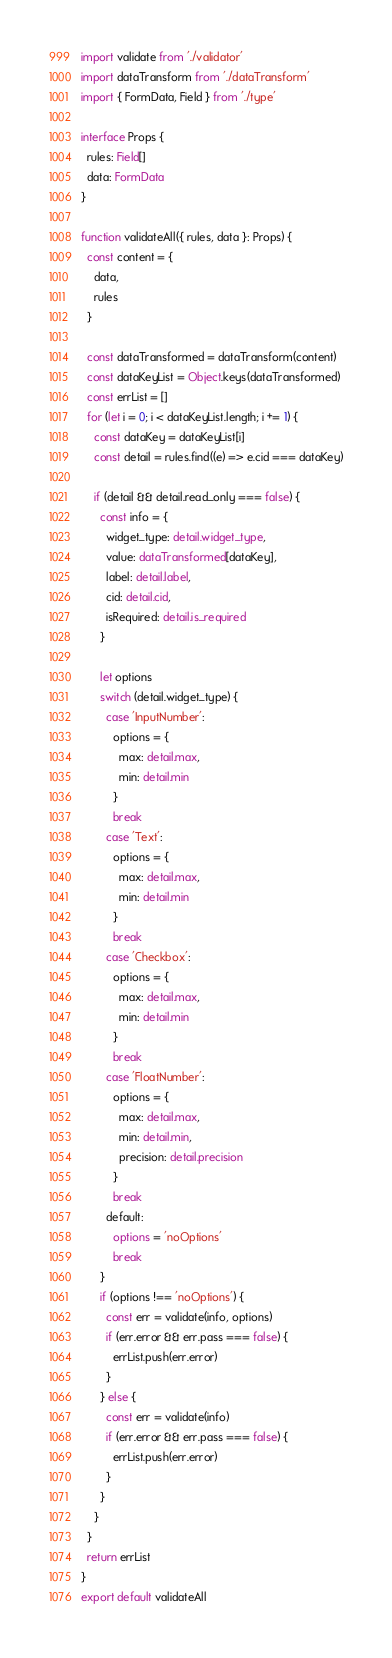Convert code to text. <code><loc_0><loc_0><loc_500><loc_500><_TypeScript_>import validate from './validator'
import dataTransform from './dataTransform'
import { FormData, Field } from './type'

interface Props {
  rules: Field[]
  data: FormData
}

function validateAll({ rules, data }: Props) {
  const content = {
    data,
    rules
  }

  const dataTransformed = dataTransform(content)
  const dataKeyList = Object.keys(dataTransformed)
  const errList = []
  for (let i = 0; i < dataKeyList.length; i += 1) {
    const dataKey = dataKeyList[i]
    const detail = rules.find((e) => e.cid === dataKey)

    if (detail && detail.read_only === false) {
      const info = {
        widget_type: detail.widget_type,
        value: dataTransformed[dataKey],
        label: detail.label,
        cid: detail.cid,
        isRequired: detail.is_required
      }

      let options
      switch (detail.widget_type) {
        case 'InputNumber':
          options = {
            max: detail.max,
            min: detail.min
          }
          break
        case 'Text':
          options = {
            max: detail.max,
            min: detail.min
          }
          break
        case 'Checkbox':
          options = {
            max: detail.max,
            min: detail.min
          }
          break
        case 'FloatNumber':
          options = {
            max: detail.max,
            min: detail.min,
            precision: detail.precision
          }
          break
        default:
          options = 'noOptions'
          break
      }
      if (options !== 'noOptions') {
        const err = validate(info, options)
        if (err.error && err.pass === false) {
          errList.push(err.error)
        }
      } else {
        const err = validate(info)
        if (err.error && err.pass === false) {
          errList.push(err.error)
        }
      }
    }
  }
  return errList
}
export default validateAll
</code> 